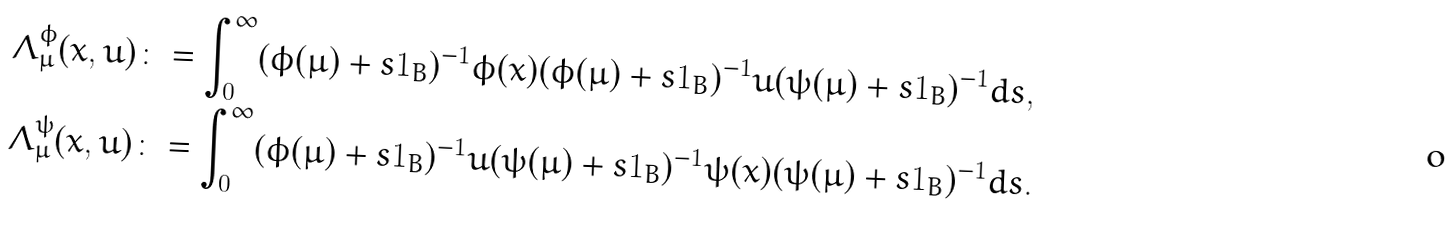Convert formula to latex. <formula><loc_0><loc_0><loc_500><loc_500>\Lambda _ { \mu } ^ { \phi } ( x , u ) & \colon = \int _ { 0 } ^ { \infty } ( \phi ( \mu ) + s 1 _ { B } ) ^ { - 1 } \phi ( x ) ( \phi ( \mu ) + s 1 _ { B } ) ^ { - 1 } u ( \psi ( \mu ) + s 1 _ { B } ) ^ { - 1 } d s , \\ \Lambda _ { \mu } ^ { \psi } ( x , u ) & \colon = \int _ { 0 } ^ { \infty } ( \phi ( \mu ) + s 1 _ { B } ) ^ { - 1 } u ( \psi ( \mu ) + s 1 _ { B } ) ^ { - 1 } \psi ( x ) ( \psi ( \mu ) + s 1 _ { B } ) ^ { - 1 } d s .</formula> 